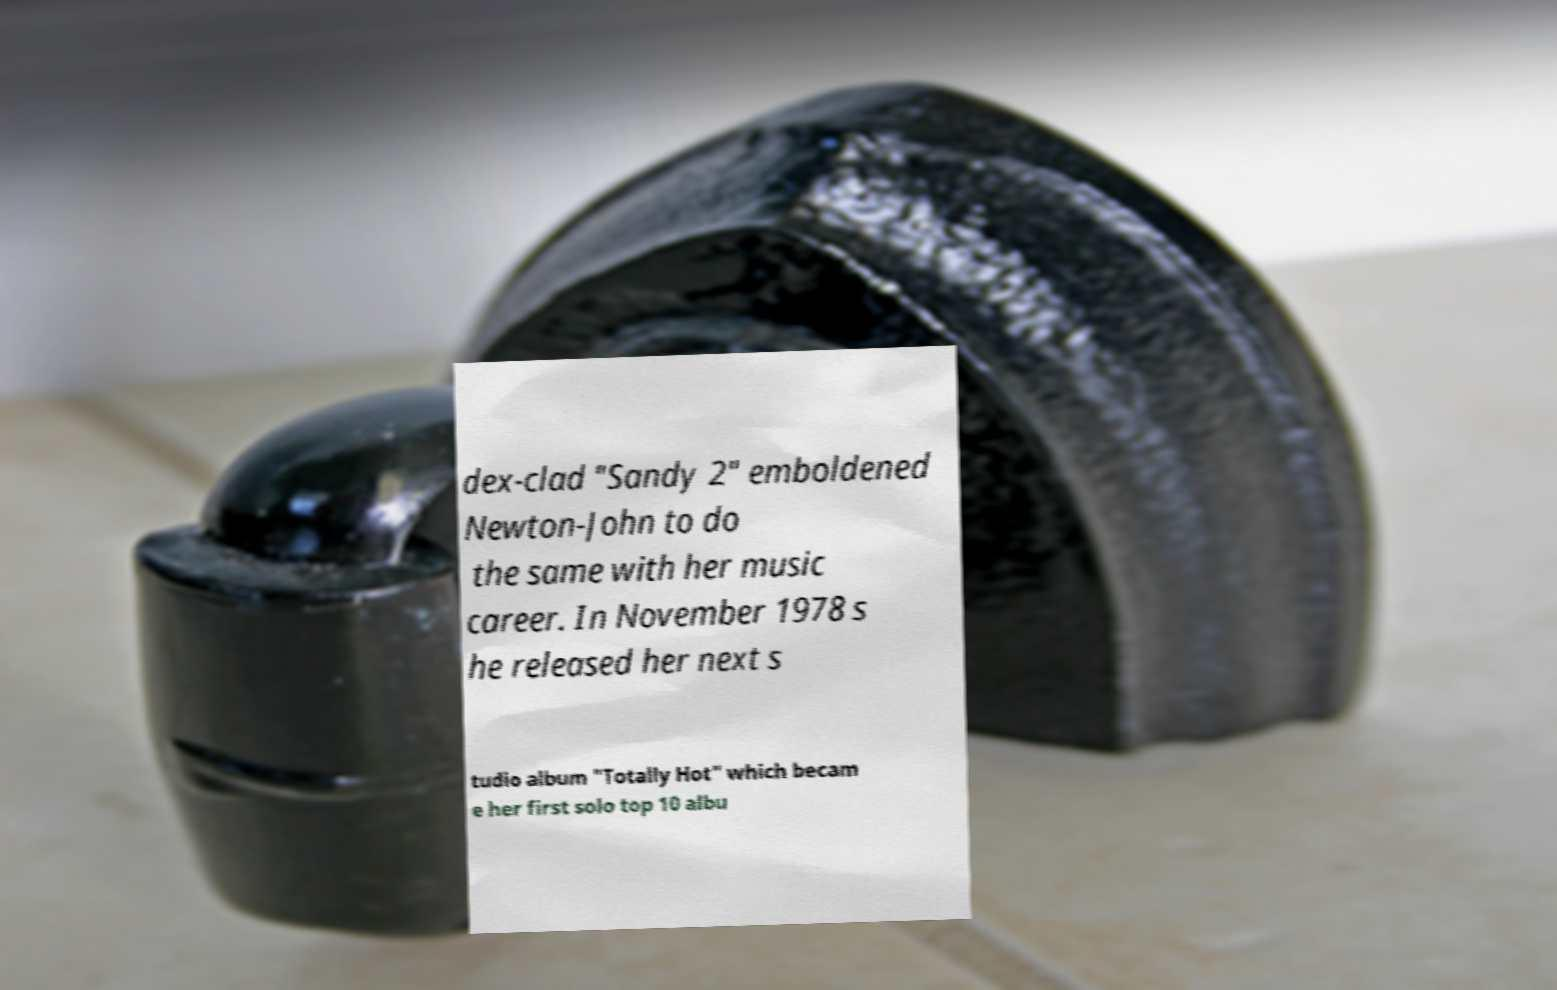Could you assist in decoding the text presented in this image and type it out clearly? dex-clad "Sandy 2" emboldened Newton-John to do the same with her music career. In November 1978 s he released her next s tudio album "Totally Hot" which becam e her first solo top 10 albu 